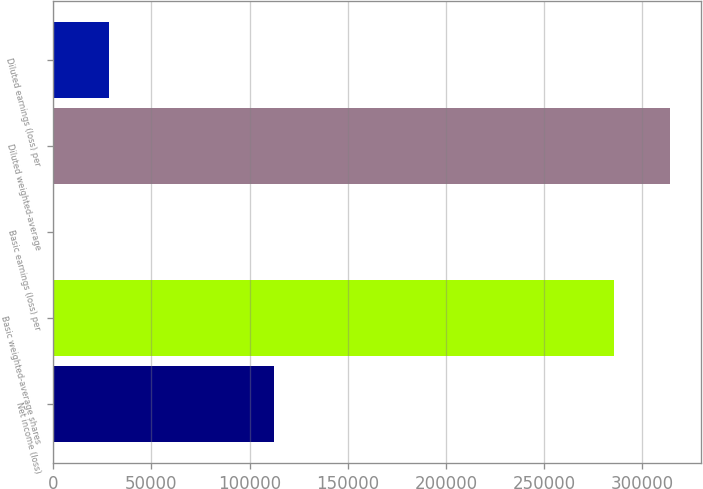<chart> <loc_0><loc_0><loc_500><loc_500><bar_chart><fcel>Net income (loss)<fcel>Basic weighted-average shares<fcel>Basic earnings (loss) per<fcel>Diluted weighted-average<fcel>Diluted earnings (loss) per<nl><fcel>112583<fcel>285748<fcel>0.39<fcel>314323<fcel>28575.2<nl></chart> 